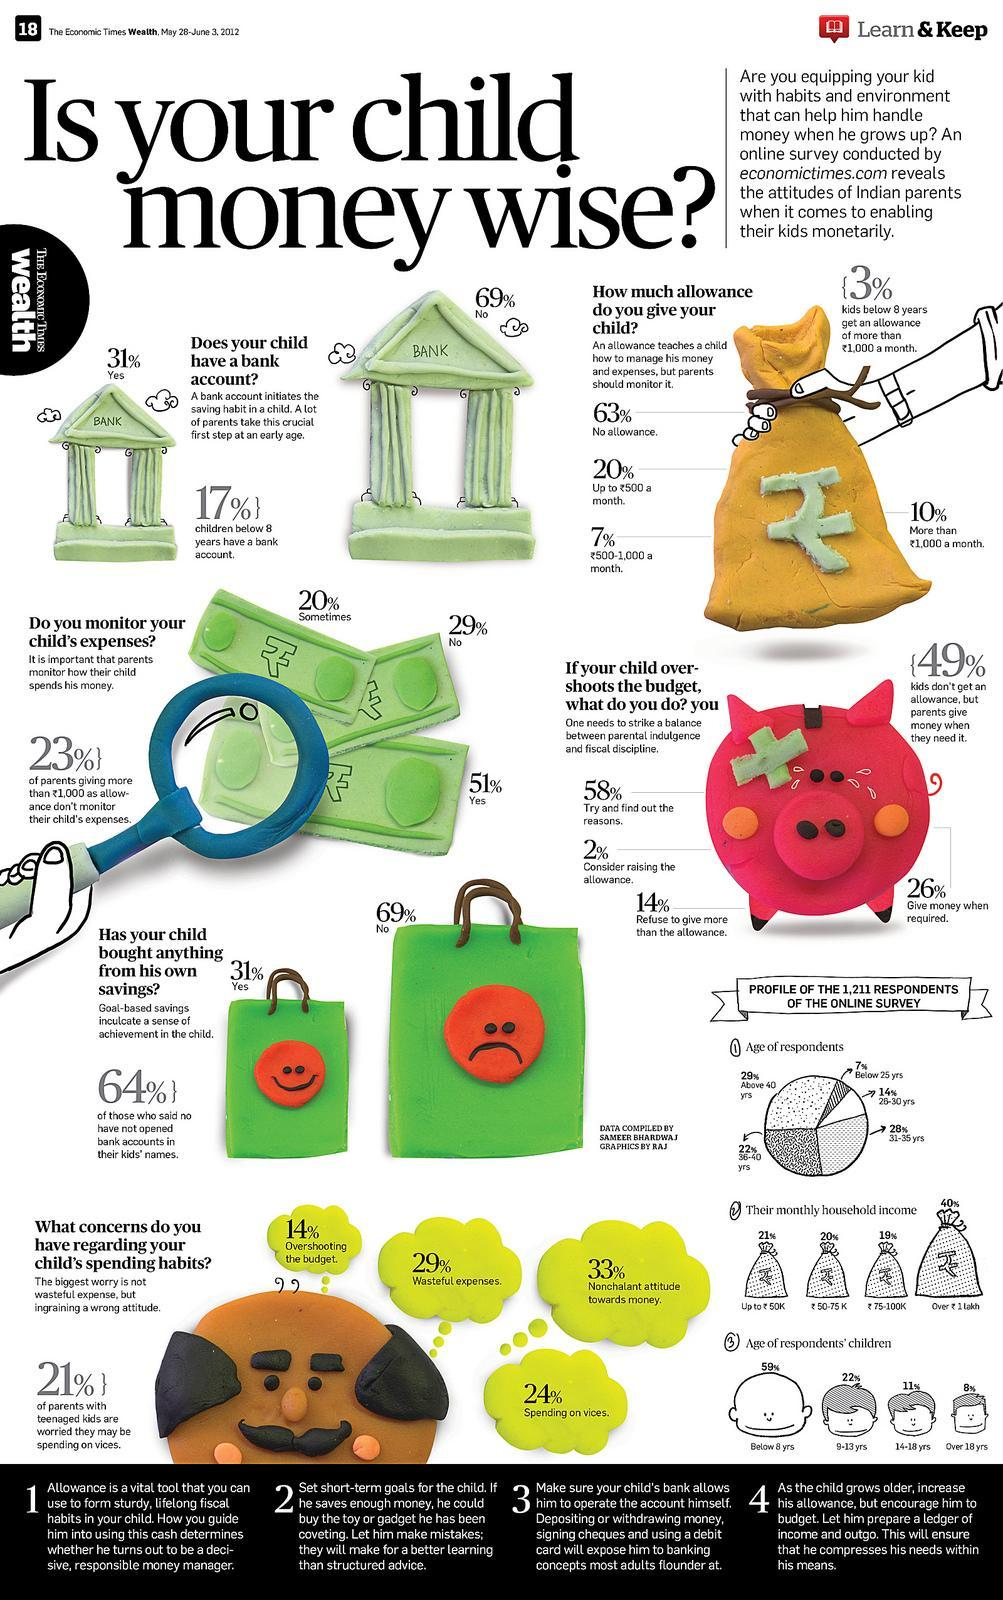What percent of children do not get an allowance at all?
Answer the question with a short phrase. 63 What percent of children below eight years have a bank account? 17% 